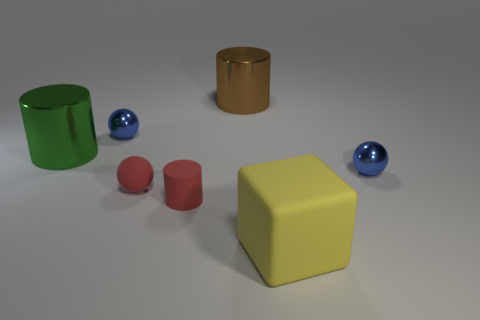Do the small red ball and the big yellow cube that is to the right of the rubber ball have the same material?
Keep it short and to the point. Yes. There is a big brown object that is the same shape as the green object; what is it made of?
Make the answer very short. Metal. Is there anything else that is the same material as the brown object?
Your answer should be very brief. Yes. Is the number of rubber cylinders that are on the left side of the big green thing greater than the number of rubber balls that are in front of the tiny rubber cylinder?
Your response must be concise. No. What shape is the big yellow thing that is made of the same material as the small cylinder?
Ensure brevity in your answer.  Cube. How many other things are there of the same shape as the big yellow matte object?
Ensure brevity in your answer.  0. There is a blue thing that is on the right side of the red cylinder; what is its shape?
Ensure brevity in your answer.  Sphere. The tiny matte ball is what color?
Your answer should be compact. Red. How many other objects are there of the same size as the red rubber cylinder?
Ensure brevity in your answer.  3. The small blue object that is left of the sphere right of the small red sphere is made of what material?
Keep it short and to the point. Metal. 